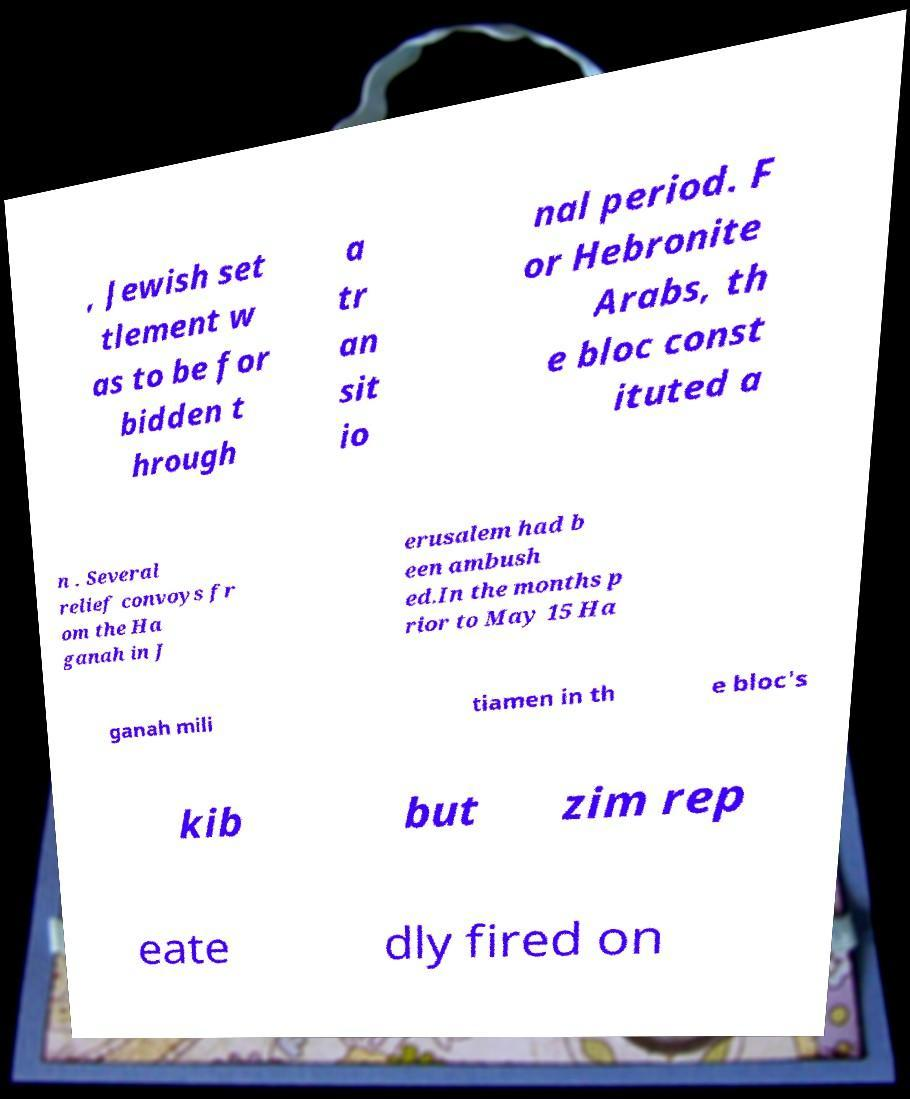Please read and relay the text visible in this image. What does it say? , Jewish set tlement w as to be for bidden t hrough a tr an sit io nal period. F or Hebronite Arabs, th e bloc const ituted a n . Several relief convoys fr om the Ha ganah in J erusalem had b een ambush ed.In the months p rior to May 15 Ha ganah mili tiamen in th e bloc's kib but zim rep eate dly fired on 